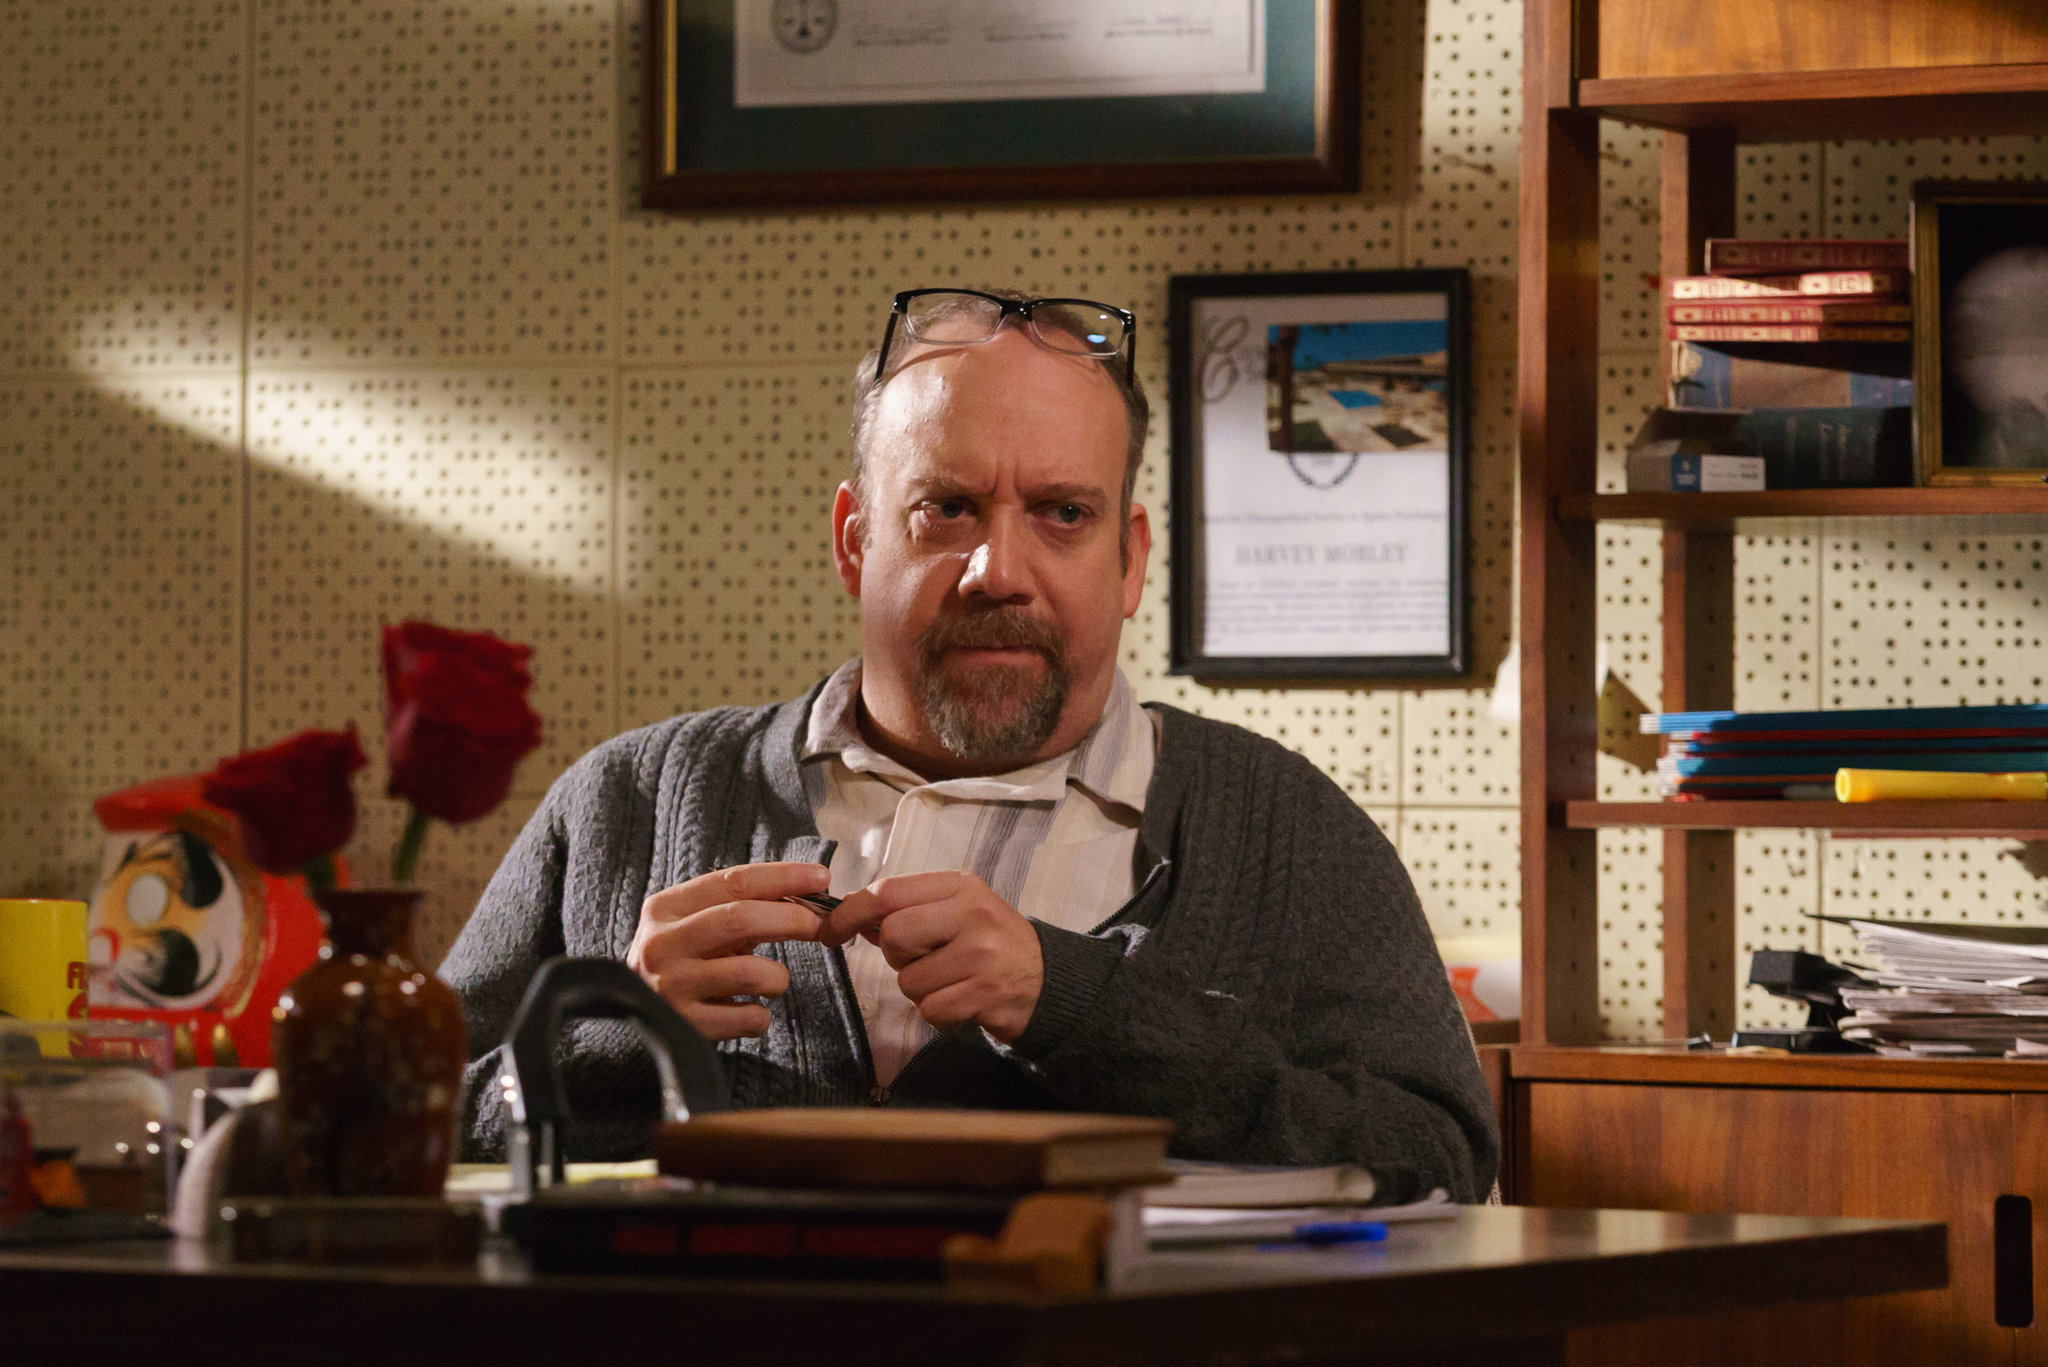Can you imagine what the man might be thinking about? It’s intriguing to imagine what might be running through his mind. Given the serious expression and the pen in hand, he could be pondering over a complex problem or reflecting on important decisions. Perhaps he's a writer perfecting his manuscript, a scientist reviewing critical data, or a professor preparing a lecture. The documents and books surrounding him hint at a mind engaged in deep, thoughtful work, possibly striving to unravel a tough intellectual challenge or preparing to communicate significant ideas. 